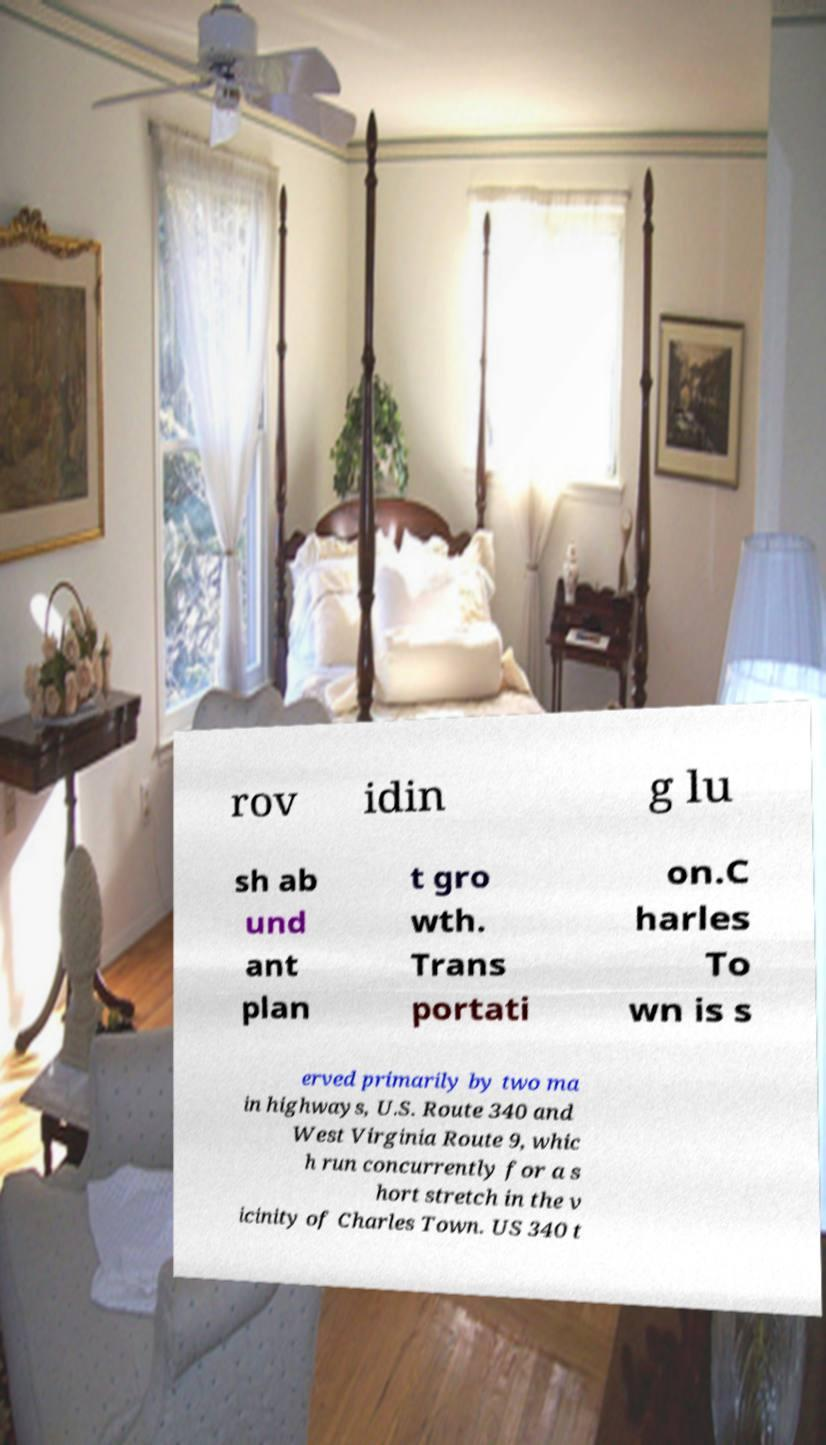For documentation purposes, I need the text within this image transcribed. Could you provide that? rov idin g lu sh ab und ant plan t gro wth. Trans portati on.C harles To wn is s erved primarily by two ma in highways, U.S. Route 340 and West Virginia Route 9, whic h run concurrently for a s hort stretch in the v icinity of Charles Town. US 340 t 